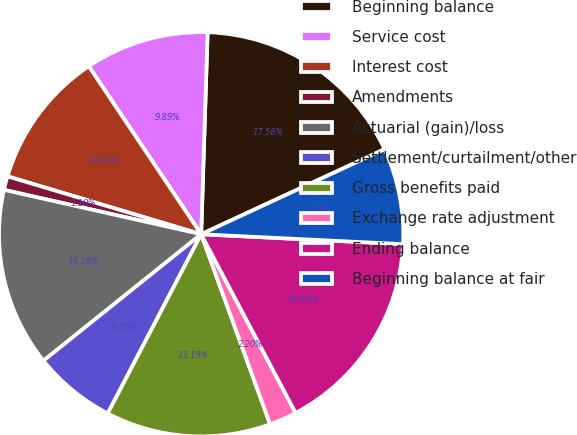<chart> <loc_0><loc_0><loc_500><loc_500><pie_chart><fcel>Beginning balance<fcel>Service cost<fcel>Interest cost<fcel>Amendments<fcel>Actuarial (gain)/loss<fcel>Settlement/curtailment/other<fcel>Gross benefits paid<fcel>Exchange rate adjustment<fcel>Ending balance<fcel>Beginning balance at fair<nl><fcel>17.58%<fcel>9.89%<fcel>10.99%<fcel>1.1%<fcel>14.28%<fcel>6.59%<fcel>13.19%<fcel>2.2%<fcel>16.48%<fcel>7.69%<nl></chart> 